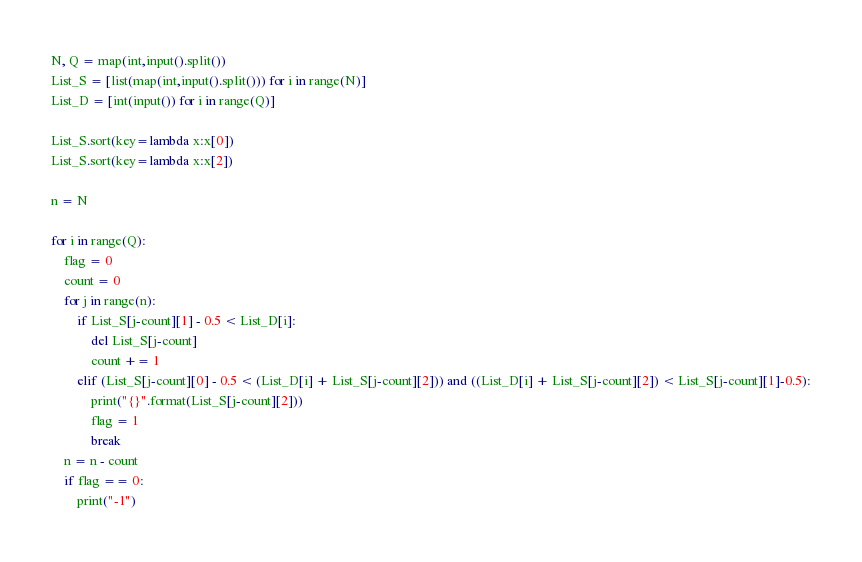<code> <loc_0><loc_0><loc_500><loc_500><_Python_>N, Q = map(int,input().split())
List_S = [list(map(int,input().split())) for i in range(N)]
List_D = [int(input()) for i in range(Q)]

List_S.sort(key=lambda x:x[0])
List_S.sort(key=lambda x:x[2])

n = N

for i in range(Q):
    flag = 0
    count = 0
    for j in range(n):
        if List_S[j-count][1] - 0.5 < List_D[i]:
            del List_S[j-count]
            count += 1
        elif (List_S[j-count][0] - 0.5 < (List_D[i] + List_S[j-count][2])) and ((List_D[i] + List_S[j-count][2]) < List_S[j-count][1]-0.5):
            print("{}".format(List_S[j-count][2]))
            flag = 1
            break
    n = n - count
    if flag == 0:
        print("-1")</code> 